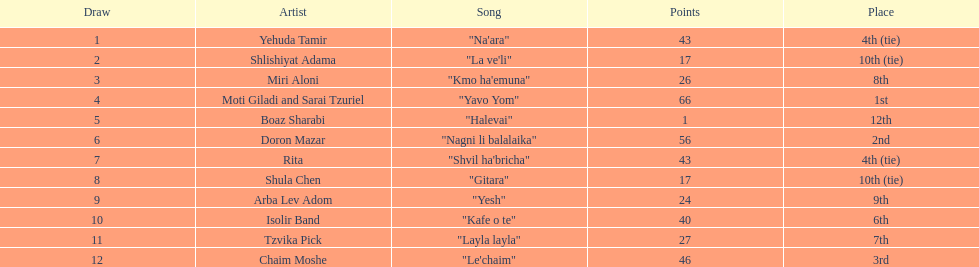What is the total number of points for the artist rita? 43. 